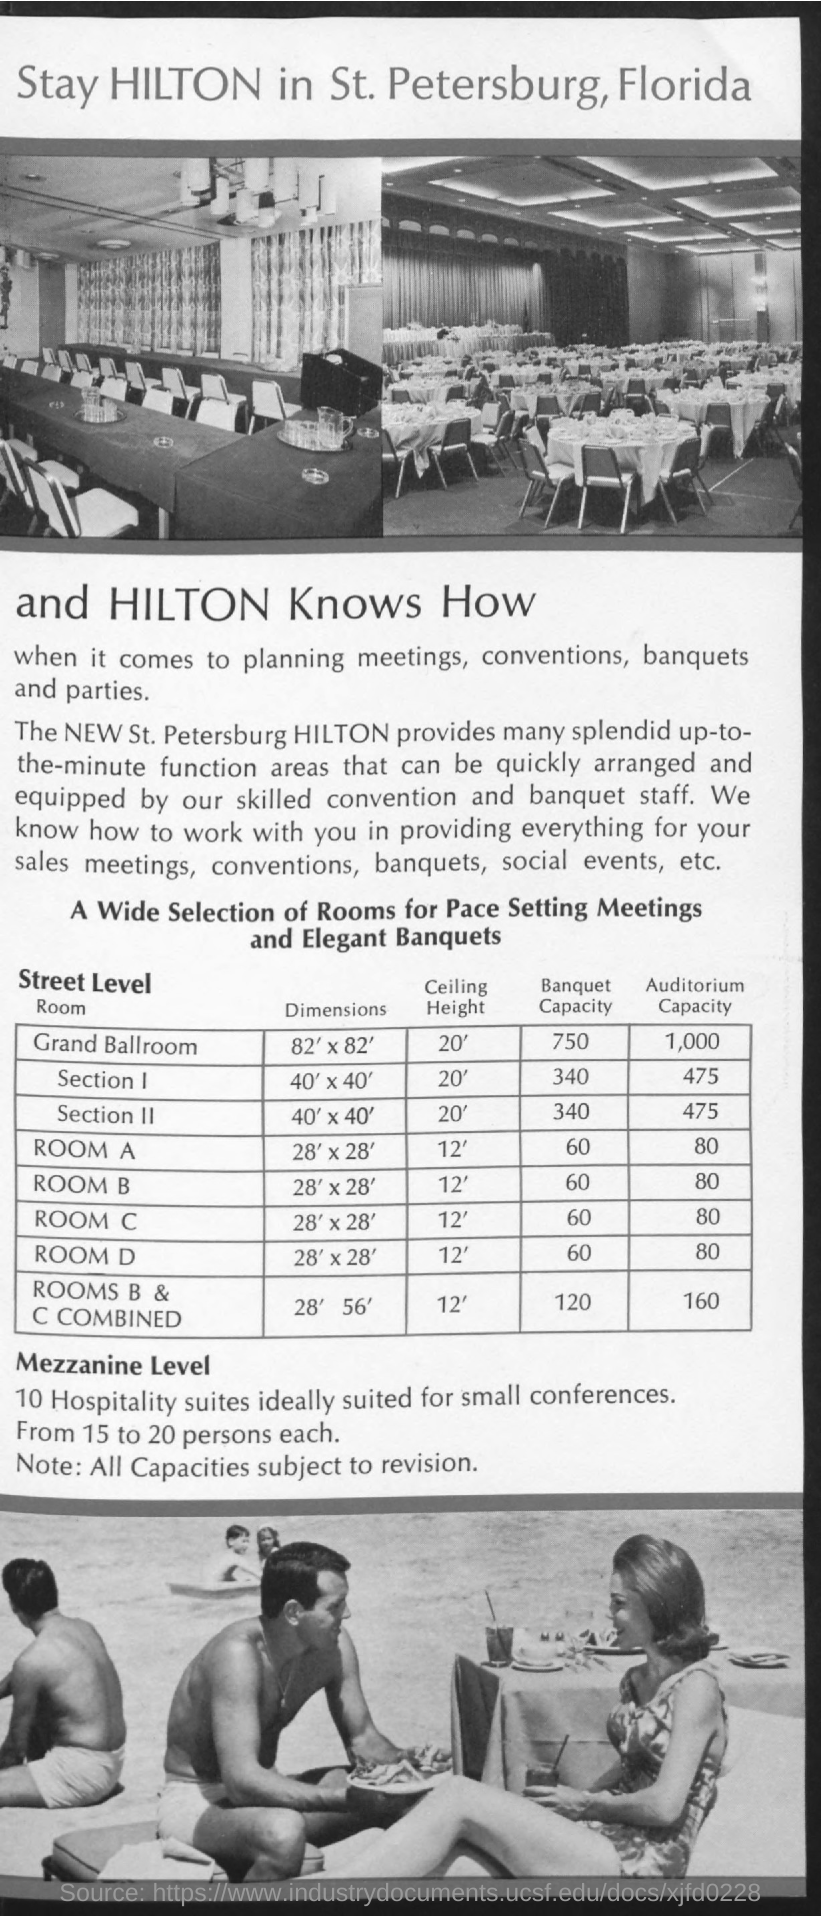Are there any spaces for smaller gatherings at this location? Yes, the St. Petersburg Hilton offers 10 Hospitality suites on the Mezzanine Level, which are ideally suited for small conferences and can accommodate from 15 to 20 persons each. This personalized setting is perfect for intimate gatherings, business meetings, or breakout sessions during larger events. 